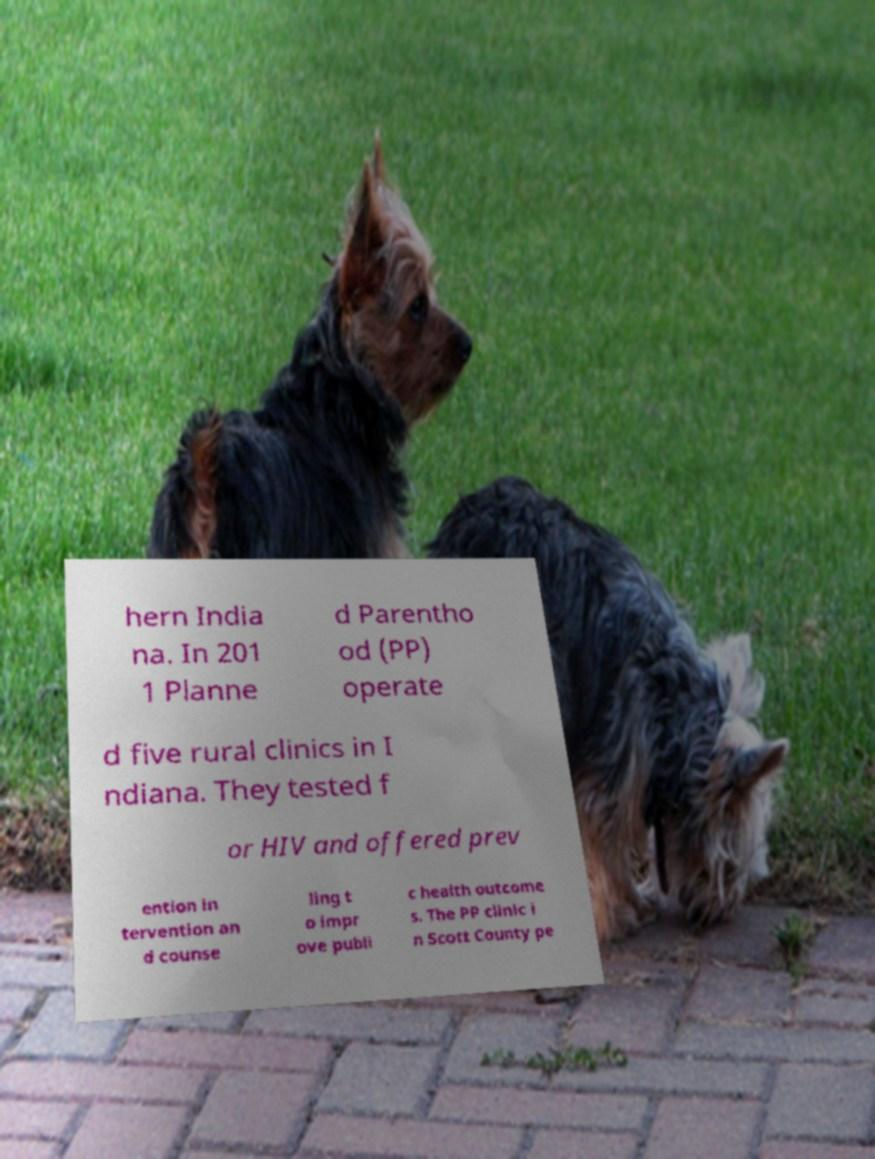Can you accurately transcribe the text from the provided image for me? hern India na. In 201 1 Planne d Parentho od (PP) operate d five rural clinics in I ndiana. They tested f or HIV and offered prev ention in tervention an d counse ling t o impr ove publi c health outcome s. The PP clinic i n Scott County pe 